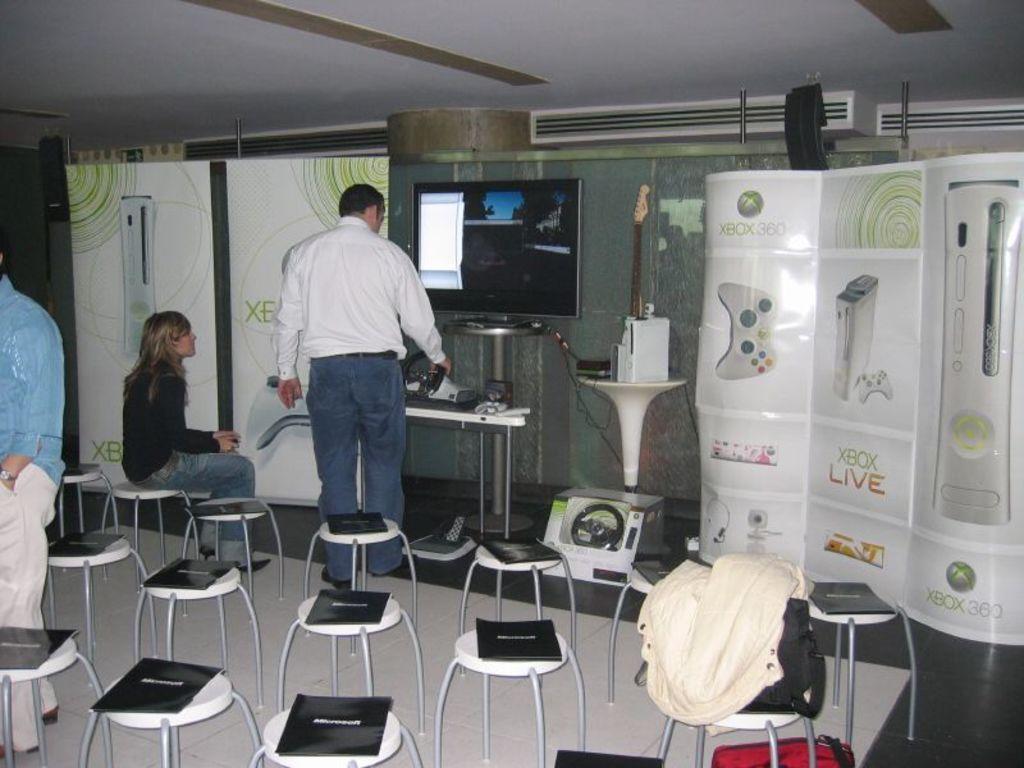What console is this event for?
Your answer should be compact. Xbox 360. 